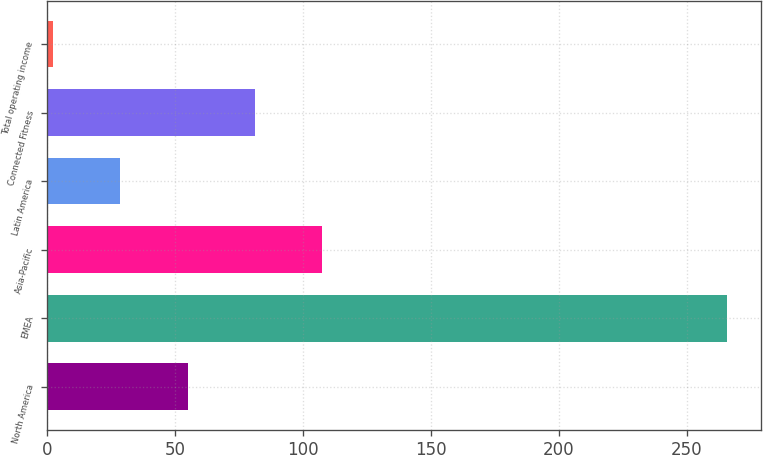<chart> <loc_0><loc_0><loc_500><loc_500><bar_chart><fcel>North America<fcel>EMEA<fcel>Asia-Pacific<fcel>Latin America<fcel>Connected Fitness<fcel>Total operating income<nl><fcel>54.92<fcel>265.8<fcel>107.64<fcel>28.56<fcel>81.28<fcel>2.2<nl></chart> 